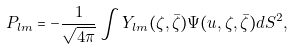Convert formula to latex. <formula><loc_0><loc_0><loc_500><loc_500>P _ { l m } = - \frac { 1 } { \sqrt { 4 \pi } } \int Y _ { l m } ( \zeta , \bar { \zeta } ) \Psi ( u , \zeta , \bar { \zeta } ) d S ^ { 2 } ,</formula> 